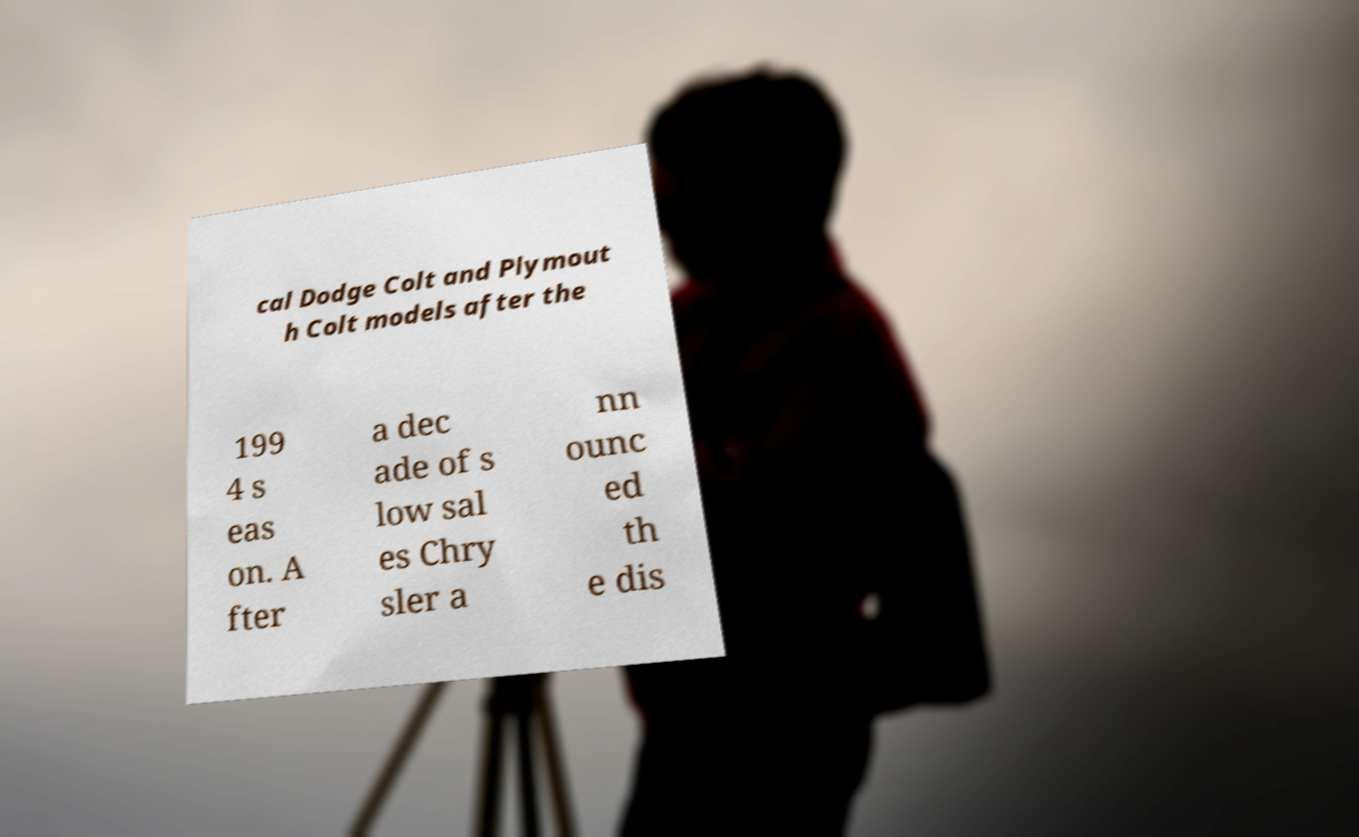Could you extract and type out the text from this image? cal Dodge Colt and Plymout h Colt models after the 199 4 s eas on. A fter a dec ade of s low sal es Chry sler a nn ounc ed th e dis 